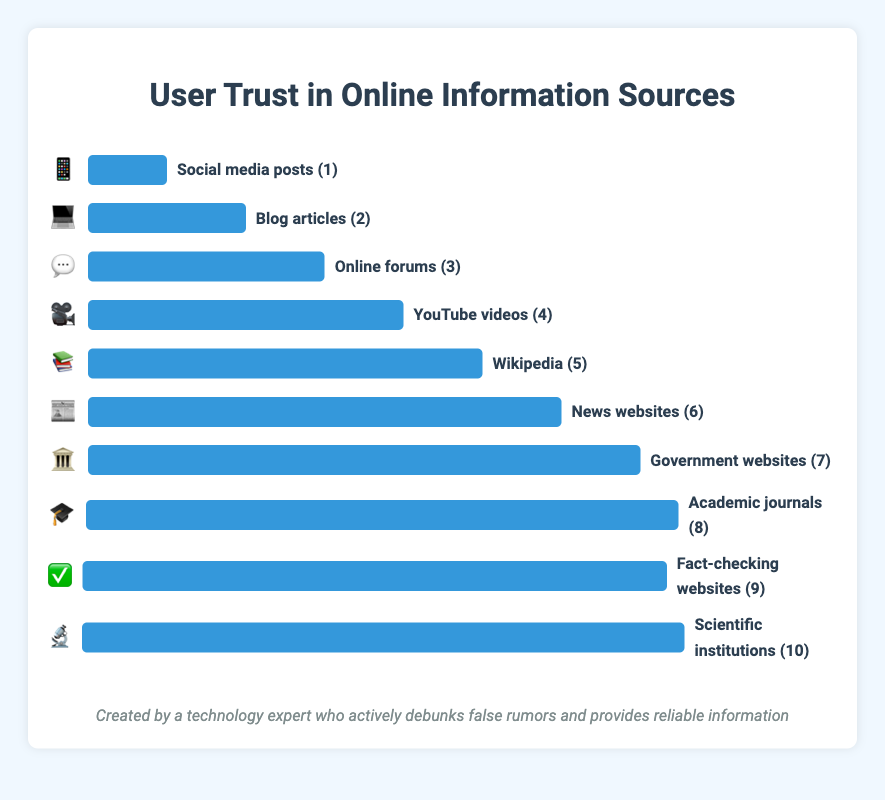Which information source has the lowest trust level? The figure shows various information sources with associated trust levels ranging from 1 to 10. The source with a trust level of 1 is "Social media posts" 📱.
Answer: Social media posts What is the title of the figure? The title is displayed at the top of the figure, giving a summary of what the figure is about. It reads "User Trust in Online Information Sources."
Answer: User Trust in Online Information Sources Which source is just above "Blog articles" in terms of trust level? "Blog articles" has a trust level of 2. The source immediately above it with a higher trust level is at level 3, which is "Online forums" 💬.
Answer: Online forums What's the trust level difference between "News websites" and "Government websites"? "News websites" have a trust level of 6, while "Government websites" have a trust level of 7. The difference between them is 7 - 6 = 1.
Answer: 1 Which source is trusted more: "YouTube videos" or "Wikipedia"? The figure shows the trust levels of "YouTube videos" 🎥 at 4 and "Wikipedia" 📚 at 5. Wikipedia has a higher trust level than YouTube videos.
Answer: Wikipedia What is the average trust level of "Social media posts," "Blog articles," and "Online forums"? The trust levels for "Social media posts" 📱, "Blog articles" 💻, and "Online forums" 💬 are 1, 2, and 3 respectively. The average is calculated as (1+2+3)/3 = 2.
Answer: 2 Which information source has the highest trust level? The figure shows various trust levels, with the highest being 10. "Scientific institutions" 🔬 have a trust level of 10.
Answer: Scientific institutions How many sources have a trust level greater than 5? By observing the figure, count the sources with a trust level above 5. These sources are "Government websites" (7), "Academic journals" (8), "Fact-checking websites" (9), and "Scientific institutions" (10), making a total of 4.
Answer: 4 What are the three least trusted sources according to the figure? The least trusted sources are those with the lowest trust levels. The figure shows these as "Social media posts" 📱 (1), "Blog articles" 💻 (2), and "Online forums" 💬 (3).
Answer: Social media posts, Blog articles, Online forums 